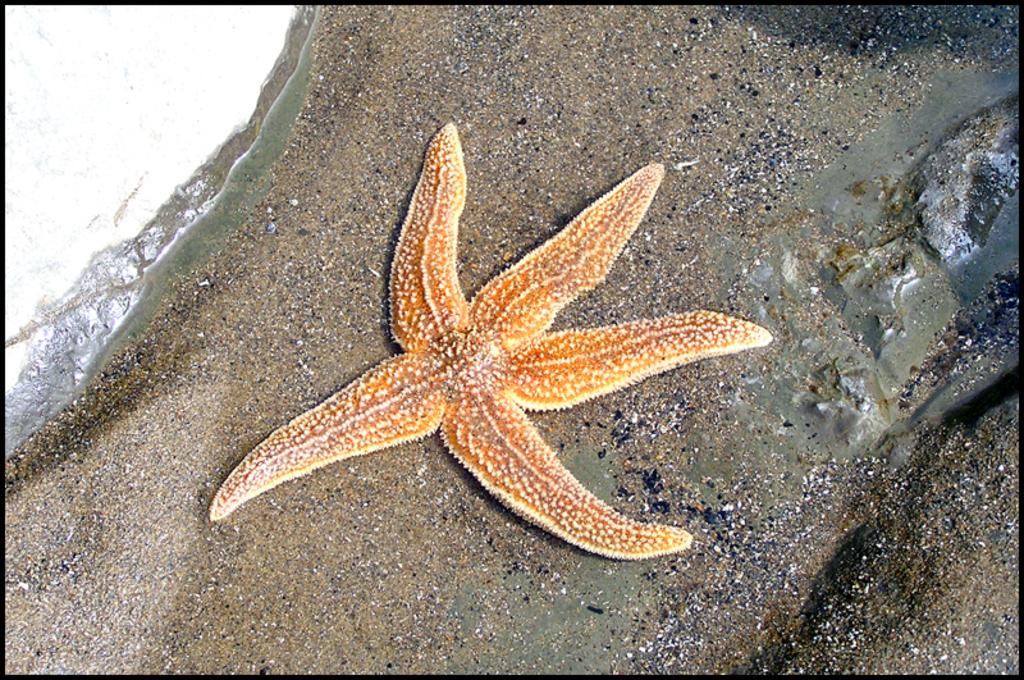What type of marine animals can be seen on the sand in the image? There are starfish on the sand in the image. What natural element is visible in the image? Water is visible in the image. What is the hen's opinion about the starfish in the image? There is no hen present in the image, so it is not possible to determine its opinion about the starfish. 